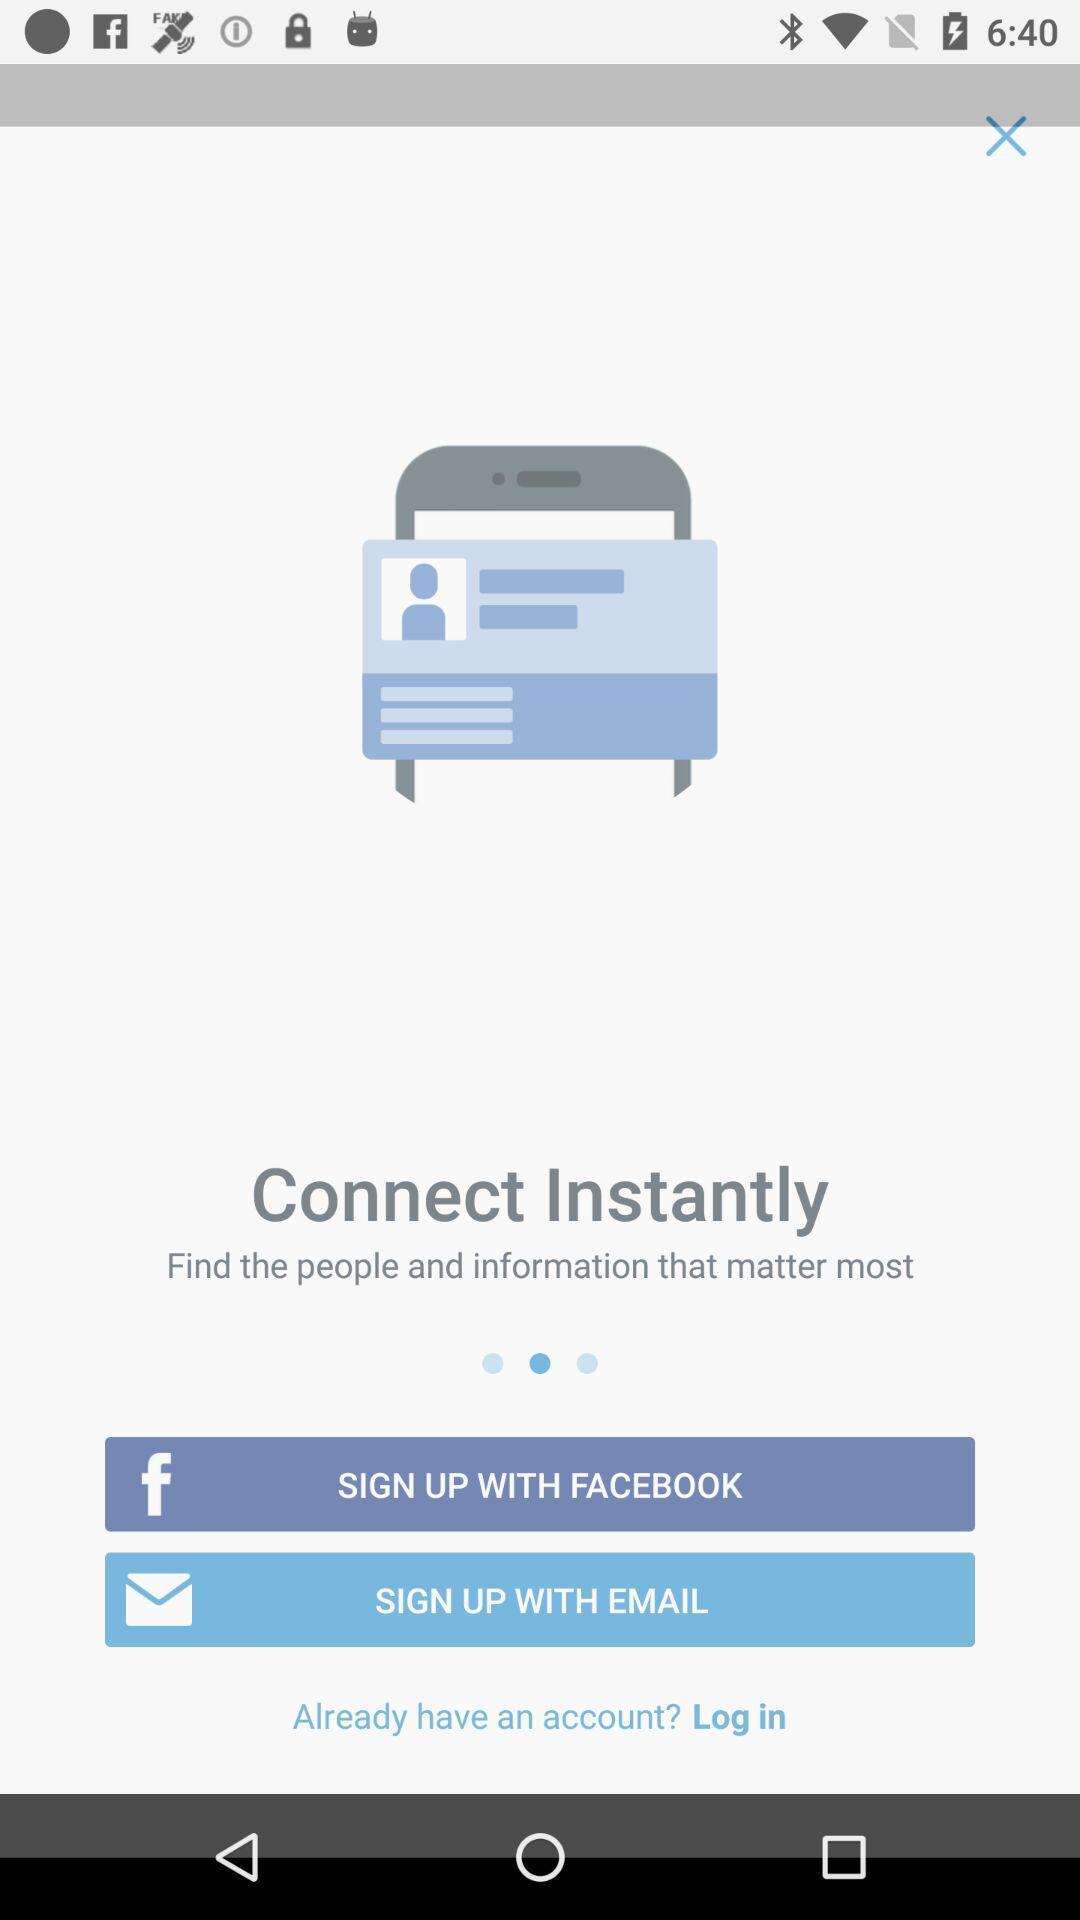Provide a description of this screenshot. Sign up page for the application. 